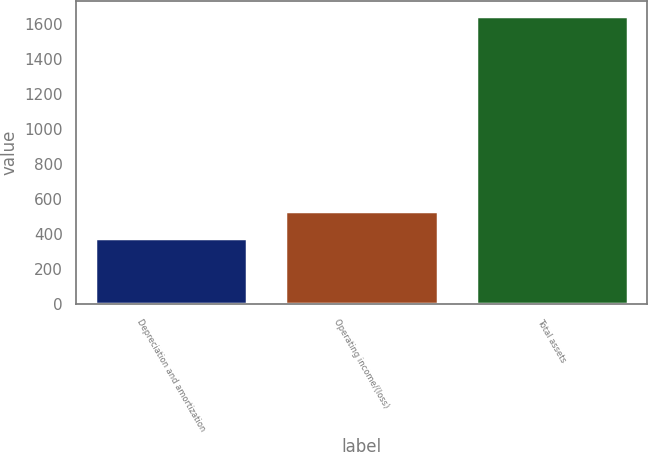Convert chart. <chart><loc_0><loc_0><loc_500><loc_500><bar_chart><fcel>Depreciation and amortization<fcel>Operating income/(loss)<fcel>Total assets<nl><fcel>378.1<fcel>531.8<fcel>1650<nl></chart> 